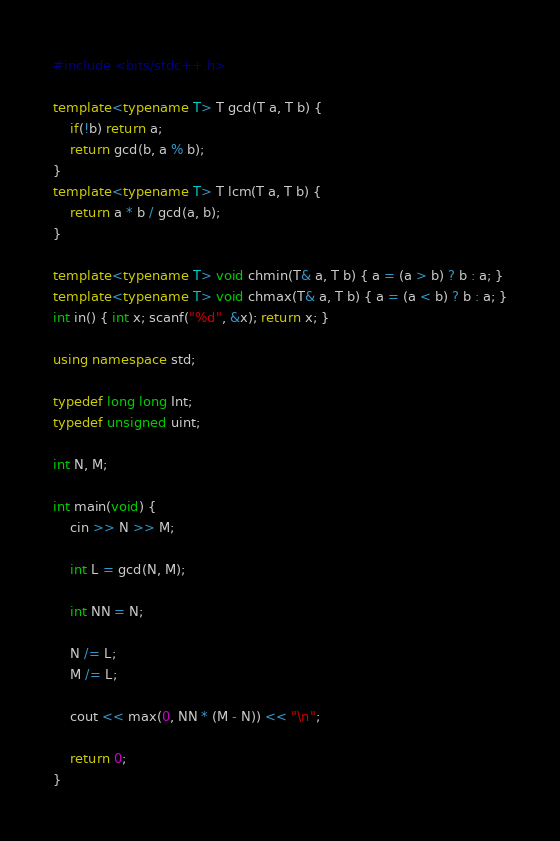Convert code to text. <code><loc_0><loc_0><loc_500><loc_500><_C++_>#include <bits/stdc++.h>

template<typename T> T gcd(T a, T b) {
    if(!b) return a;
    return gcd(b, a % b);
}
template<typename T> T lcm(T a, T b) {
    return a * b / gcd(a, b);
}

template<typename T> void chmin(T& a, T b) { a = (a > b) ? b : a; }
template<typename T> void chmax(T& a, T b) { a = (a < b) ? b : a; }
int in() { int x; scanf("%d", &x); return x; }

using namespace std;

typedef long long Int;
typedef unsigned uint;

int N, M;

int main(void) {
	cin >> N >> M;

	int L = gcd(N, M);

	int NN = N;

	N /= L;
	M /= L;

	cout << max(0, NN * (M - N)) << "\n";

    return 0;
}
</code> 